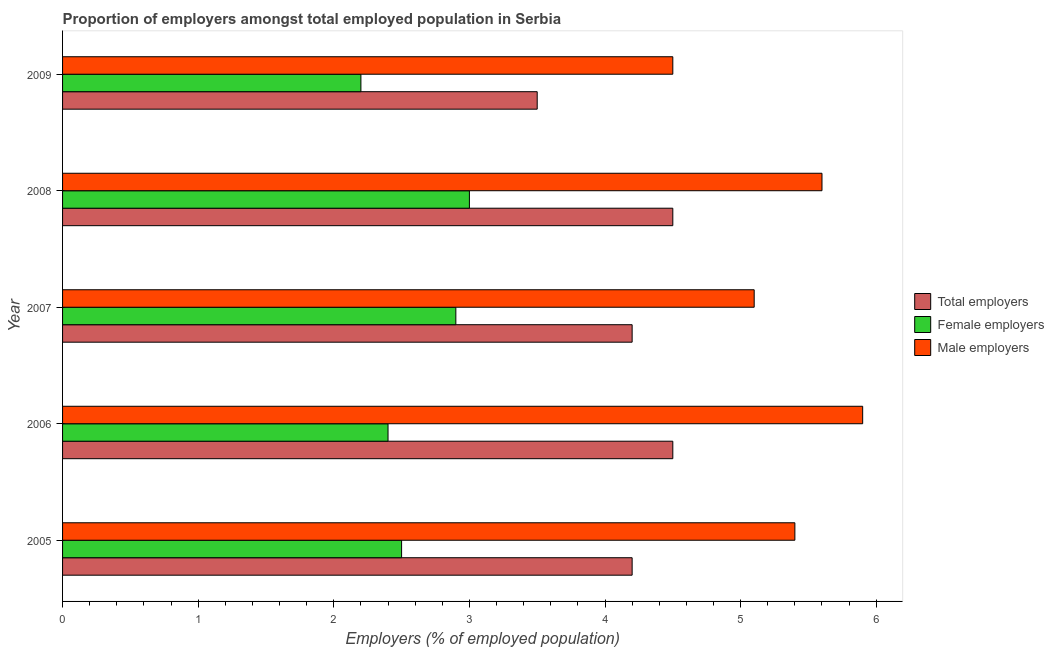How many groups of bars are there?
Give a very brief answer. 5. Are the number of bars on each tick of the Y-axis equal?
Provide a succinct answer. Yes. What is the label of the 5th group of bars from the top?
Provide a succinct answer. 2005. What is the percentage of male employers in 2007?
Provide a succinct answer. 5.1. What is the total percentage of female employers in the graph?
Give a very brief answer. 13. What is the difference between the percentage of female employers in 2009 and the percentage of male employers in 2005?
Your answer should be compact. -3.2. What is the difference between the highest and the second highest percentage of female employers?
Give a very brief answer. 0.1. What is the difference between the highest and the lowest percentage of female employers?
Provide a succinct answer. 0.8. In how many years, is the percentage of female employers greater than the average percentage of female employers taken over all years?
Offer a terse response. 2. What does the 2nd bar from the top in 2009 represents?
Your response must be concise. Female employers. What does the 1st bar from the bottom in 2007 represents?
Offer a terse response. Total employers. How many bars are there?
Provide a succinct answer. 15. Are all the bars in the graph horizontal?
Provide a short and direct response. Yes. How many years are there in the graph?
Make the answer very short. 5. What is the difference between two consecutive major ticks on the X-axis?
Offer a very short reply. 1. Does the graph contain grids?
Your response must be concise. No. Where does the legend appear in the graph?
Offer a very short reply. Center right. How are the legend labels stacked?
Ensure brevity in your answer.  Vertical. What is the title of the graph?
Ensure brevity in your answer.  Proportion of employers amongst total employed population in Serbia. Does "Private sector" appear as one of the legend labels in the graph?
Your answer should be compact. No. What is the label or title of the X-axis?
Give a very brief answer. Employers (% of employed population). What is the label or title of the Y-axis?
Your answer should be compact. Year. What is the Employers (% of employed population) of Total employers in 2005?
Your response must be concise. 4.2. What is the Employers (% of employed population) of Female employers in 2005?
Your response must be concise. 2.5. What is the Employers (% of employed population) in Male employers in 2005?
Ensure brevity in your answer.  5.4. What is the Employers (% of employed population) of Total employers in 2006?
Your answer should be compact. 4.5. What is the Employers (% of employed population) of Female employers in 2006?
Ensure brevity in your answer.  2.4. What is the Employers (% of employed population) of Male employers in 2006?
Your response must be concise. 5.9. What is the Employers (% of employed population) in Total employers in 2007?
Offer a terse response. 4.2. What is the Employers (% of employed population) of Female employers in 2007?
Provide a succinct answer. 2.9. What is the Employers (% of employed population) of Male employers in 2007?
Provide a succinct answer. 5.1. What is the Employers (% of employed population) in Female employers in 2008?
Provide a succinct answer. 3. What is the Employers (% of employed population) of Male employers in 2008?
Your answer should be very brief. 5.6. What is the Employers (% of employed population) in Total employers in 2009?
Provide a short and direct response. 3.5. What is the Employers (% of employed population) of Female employers in 2009?
Give a very brief answer. 2.2. Across all years, what is the maximum Employers (% of employed population) in Female employers?
Keep it short and to the point. 3. Across all years, what is the maximum Employers (% of employed population) in Male employers?
Your response must be concise. 5.9. Across all years, what is the minimum Employers (% of employed population) in Total employers?
Provide a short and direct response. 3.5. Across all years, what is the minimum Employers (% of employed population) of Female employers?
Give a very brief answer. 2.2. What is the total Employers (% of employed population) of Total employers in the graph?
Make the answer very short. 20.9. What is the total Employers (% of employed population) in Female employers in the graph?
Your answer should be compact. 13. What is the total Employers (% of employed population) in Male employers in the graph?
Your answer should be very brief. 26.5. What is the difference between the Employers (% of employed population) of Total employers in 2005 and that in 2006?
Your answer should be very brief. -0.3. What is the difference between the Employers (% of employed population) of Female employers in 2005 and that in 2006?
Give a very brief answer. 0.1. What is the difference between the Employers (% of employed population) in Male employers in 2005 and that in 2007?
Provide a succinct answer. 0.3. What is the difference between the Employers (% of employed population) in Total employers in 2005 and that in 2008?
Ensure brevity in your answer.  -0.3. What is the difference between the Employers (% of employed population) of Male employers in 2005 and that in 2008?
Ensure brevity in your answer.  -0.2. What is the difference between the Employers (% of employed population) in Total employers in 2005 and that in 2009?
Keep it short and to the point. 0.7. What is the difference between the Employers (% of employed population) in Total employers in 2006 and that in 2007?
Your answer should be compact. 0.3. What is the difference between the Employers (% of employed population) of Female employers in 2006 and that in 2007?
Keep it short and to the point. -0.5. What is the difference between the Employers (% of employed population) of Female employers in 2006 and that in 2008?
Ensure brevity in your answer.  -0.6. What is the difference between the Employers (% of employed population) of Total employers in 2006 and that in 2009?
Provide a short and direct response. 1. What is the difference between the Employers (% of employed population) of Female employers in 2006 and that in 2009?
Make the answer very short. 0.2. What is the difference between the Employers (% of employed population) of Total employers in 2007 and that in 2008?
Provide a succinct answer. -0.3. What is the difference between the Employers (% of employed population) in Female employers in 2007 and that in 2008?
Provide a short and direct response. -0.1. What is the difference between the Employers (% of employed population) in Total employers in 2007 and that in 2009?
Your response must be concise. 0.7. What is the difference between the Employers (% of employed population) in Male employers in 2008 and that in 2009?
Provide a short and direct response. 1.1. What is the difference between the Employers (% of employed population) in Total employers in 2005 and the Employers (% of employed population) in Female employers in 2006?
Offer a terse response. 1.8. What is the difference between the Employers (% of employed population) in Total employers in 2005 and the Employers (% of employed population) in Male employers in 2006?
Offer a terse response. -1.7. What is the difference between the Employers (% of employed population) in Female employers in 2005 and the Employers (% of employed population) in Male employers in 2006?
Your response must be concise. -3.4. What is the difference between the Employers (% of employed population) of Total employers in 2005 and the Employers (% of employed population) of Female employers in 2007?
Give a very brief answer. 1.3. What is the difference between the Employers (% of employed population) in Female employers in 2005 and the Employers (% of employed population) in Male employers in 2007?
Your response must be concise. -2.6. What is the difference between the Employers (% of employed population) in Female employers in 2005 and the Employers (% of employed population) in Male employers in 2009?
Keep it short and to the point. -2. What is the difference between the Employers (% of employed population) in Total employers in 2006 and the Employers (% of employed population) in Female employers in 2007?
Keep it short and to the point. 1.6. What is the difference between the Employers (% of employed population) in Total employers in 2006 and the Employers (% of employed population) in Male employers in 2007?
Your answer should be very brief. -0.6. What is the difference between the Employers (% of employed population) of Total employers in 2006 and the Employers (% of employed population) of Female employers in 2008?
Your answer should be very brief. 1.5. What is the difference between the Employers (% of employed population) in Total employers in 2006 and the Employers (% of employed population) in Male employers in 2008?
Your response must be concise. -1.1. What is the difference between the Employers (% of employed population) of Female employers in 2006 and the Employers (% of employed population) of Male employers in 2008?
Offer a very short reply. -3.2. What is the difference between the Employers (% of employed population) of Total employers in 2007 and the Employers (% of employed population) of Male employers in 2008?
Offer a terse response. -1.4. What is the difference between the Employers (% of employed population) in Female employers in 2007 and the Employers (% of employed population) in Male employers in 2008?
Offer a terse response. -2.7. What is the difference between the Employers (% of employed population) in Total employers in 2007 and the Employers (% of employed population) in Female employers in 2009?
Offer a very short reply. 2. What is the difference between the Employers (% of employed population) of Total employers in 2007 and the Employers (% of employed population) of Male employers in 2009?
Make the answer very short. -0.3. What is the difference between the Employers (% of employed population) in Female employers in 2007 and the Employers (% of employed population) in Male employers in 2009?
Keep it short and to the point. -1.6. What is the difference between the Employers (% of employed population) of Total employers in 2008 and the Employers (% of employed population) of Male employers in 2009?
Offer a terse response. 0. What is the average Employers (% of employed population) in Total employers per year?
Ensure brevity in your answer.  4.18. What is the average Employers (% of employed population) of Female employers per year?
Your answer should be very brief. 2.6. What is the average Employers (% of employed population) in Male employers per year?
Offer a terse response. 5.3. In the year 2005, what is the difference between the Employers (% of employed population) of Total employers and Employers (% of employed population) of Female employers?
Your response must be concise. 1.7. In the year 2005, what is the difference between the Employers (% of employed population) in Female employers and Employers (% of employed population) in Male employers?
Provide a short and direct response. -2.9. In the year 2006, what is the difference between the Employers (% of employed population) of Total employers and Employers (% of employed population) of Male employers?
Make the answer very short. -1.4. In the year 2006, what is the difference between the Employers (% of employed population) in Female employers and Employers (% of employed population) in Male employers?
Give a very brief answer. -3.5. In the year 2007, what is the difference between the Employers (% of employed population) in Total employers and Employers (% of employed population) in Male employers?
Offer a very short reply. -0.9. In the year 2009, what is the difference between the Employers (% of employed population) in Total employers and Employers (% of employed population) in Male employers?
Provide a succinct answer. -1. In the year 2009, what is the difference between the Employers (% of employed population) of Female employers and Employers (% of employed population) of Male employers?
Ensure brevity in your answer.  -2.3. What is the ratio of the Employers (% of employed population) of Female employers in 2005 to that in 2006?
Keep it short and to the point. 1.04. What is the ratio of the Employers (% of employed population) of Male employers in 2005 to that in 2006?
Keep it short and to the point. 0.92. What is the ratio of the Employers (% of employed population) in Female employers in 2005 to that in 2007?
Offer a very short reply. 0.86. What is the ratio of the Employers (% of employed population) in Male employers in 2005 to that in 2007?
Offer a terse response. 1.06. What is the ratio of the Employers (% of employed population) of Female employers in 2005 to that in 2008?
Make the answer very short. 0.83. What is the ratio of the Employers (% of employed population) in Total employers in 2005 to that in 2009?
Ensure brevity in your answer.  1.2. What is the ratio of the Employers (% of employed population) in Female employers in 2005 to that in 2009?
Offer a very short reply. 1.14. What is the ratio of the Employers (% of employed population) in Male employers in 2005 to that in 2009?
Your answer should be very brief. 1.2. What is the ratio of the Employers (% of employed population) in Total employers in 2006 to that in 2007?
Offer a very short reply. 1.07. What is the ratio of the Employers (% of employed population) in Female employers in 2006 to that in 2007?
Ensure brevity in your answer.  0.83. What is the ratio of the Employers (% of employed population) in Male employers in 2006 to that in 2007?
Ensure brevity in your answer.  1.16. What is the ratio of the Employers (% of employed population) of Total employers in 2006 to that in 2008?
Your answer should be very brief. 1. What is the ratio of the Employers (% of employed population) of Male employers in 2006 to that in 2008?
Make the answer very short. 1.05. What is the ratio of the Employers (% of employed population) in Total employers in 2006 to that in 2009?
Make the answer very short. 1.29. What is the ratio of the Employers (% of employed population) in Female employers in 2006 to that in 2009?
Your response must be concise. 1.09. What is the ratio of the Employers (% of employed population) in Male employers in 2006 to that in 2009?
Give a very brief answer. 1.31. What is the ratio of the Employers (% of employed population) of Total employers in 2007 to that in 2008?
Offer a very short reply. 0.93. What is the ratio of the Employers (% of employed population) of Female employers in 2007 to that in 2008?
Your answer should be compact. 0.97. What is the ratio of the Employers (% of employed population) of Male employers in 2007 to that in 2008?
Give a very brief answer. 0.91. What is the ratio of the Employers (% of employed population) of Female employers in 2007 to that in 2009?
Your answer should be very brief. 1.32. What is the ratio of the Employers (% of employed population) in Male employers in 2007 to that in 2009?
Offer a very short reply. 1.13. What is the ratio of the Employers (% of employed population) of Total employers in 2008 to that in 2009?
Your response must be concise. 1.29. What is the ratio of the Employers (% of employed population) in Female employers in 2008 to that in 2009?
Your answer should be compact. 1.36. What is the ratio of the Employers (% of employed population) of Male employers in 2008 to that in 2009?
Your response must be concise. 1.24. What is the difference between the highest and the second highest Employers (% of employed population) of Female employers?
Make the answer very short. 0.1. What is the difference between the highest and the second highest Employers (% of employed population) in Male employers?
Ensure brevity in your answer.  0.3. What is the difference between the highest and the lowest Employers (% of employed population) of Total employers?
Your response must be concise. 1. What is the difference between the highest and the lowest Employers (% of employed population) in Female employers?
Keep it short and to the point. 0.8. 